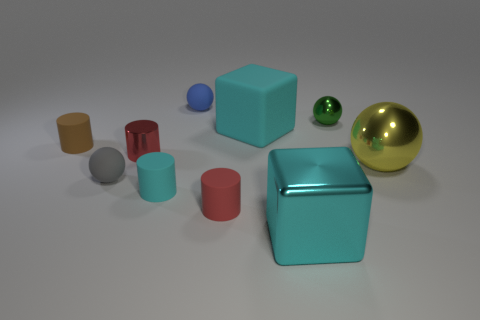Subtract 1 cylinders. How many cylinders are left? 3 Subtract all blocks. How many objects are left? 8 Subtract all tiny red shiny cylinders. Subtract all large matte spheres. How many objects are left? 9 Add 3 metal blocks. How many metal blocks are left? 4 Add 1 tiny cyan rubber cylinders. How many tiny cyan rubber cylinders exist? 2 Subtract 0 cyan balls. How many objects are left? 10 